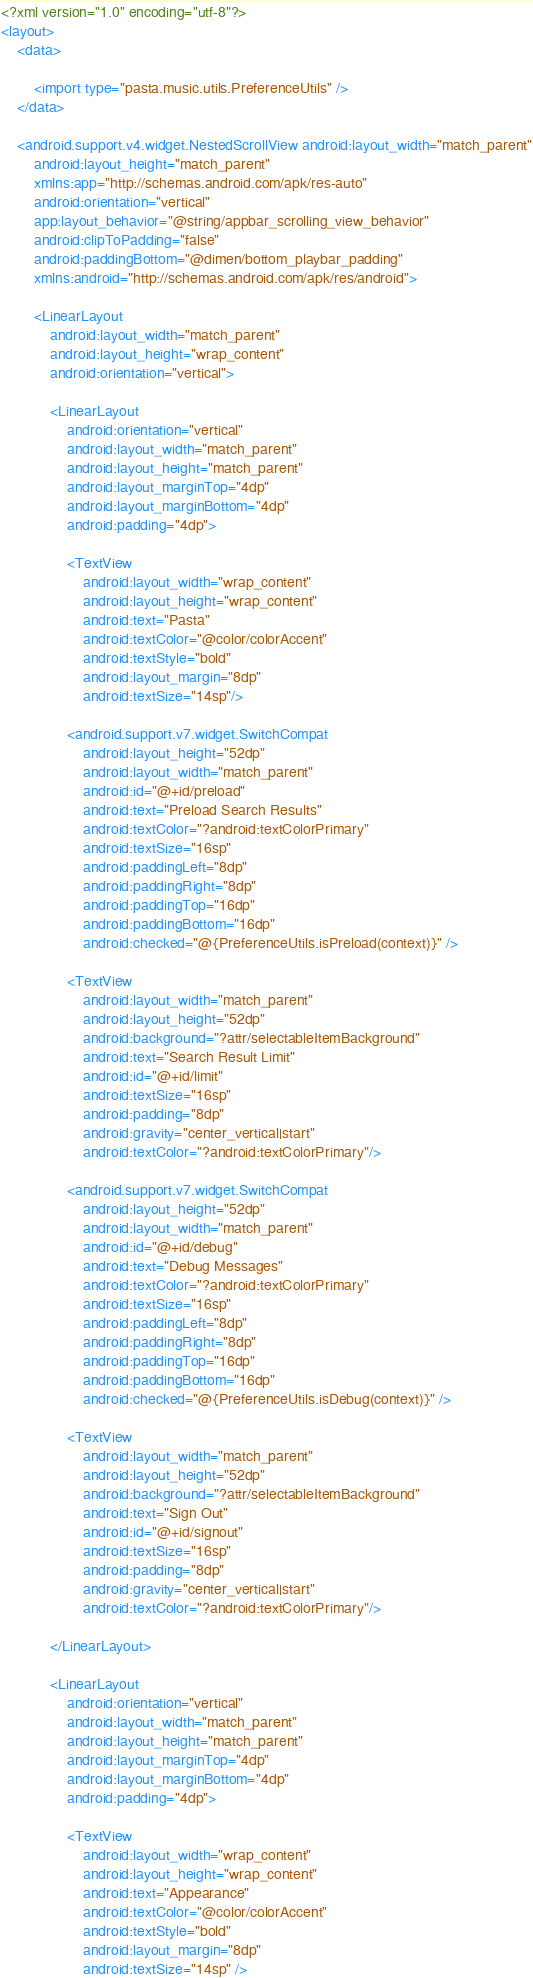Convert code to text. <code><loc_0><loc_0><loc_500><loc_500><_XML_><?xml version="1.0" encoding="utf-8"?>
<layout>
    <data>

        <import type="pasta.music.utils.PreferenceUtils" />
    </data>

    <android.support.v4.widget.NestedScrollView android:layout_width="match_parent"
        android:layout_height="match_parent"
        xmlns:app="http://schemas.android.com/apk/res-auto"
        android:orientation="vertical"
        app:layout_behavior="@string/appbar_scrolling_view_behavior"
        android:clipToPadding="false"
        android:paddingBottom="@dimen/bottom_playbar_padding"
        xmlns:android="http://schemas.android.com/apk/res/android">

        <LinearLayout
            android:layout_width="match_parent"
            android:layout_height="wrap_content"
            android:orientation="vertical">

            <LinearLayout
                android:orientation="vertical"
                android:layout_width="match_parent"
                android:layout_height="match_parent"
                android:layout_marginTop="4dp"
                android:layout_marginBottom="4dp"
                android:padding="4dp">

                <TextView
                    android:layout_width="wrap_content"
                    android:layout_height="wrap_content"
                    android:text="Pasta"
                    android:textColor="@color/colorAccent"
                    android:textStyle="bold"
                    android:layout_margin="8dp"
                    android:textSize="14sp"/>

                <android.support.v7.widget.SwitchCompat
                    android:layout_height="52dp"
                    android:layout_width="match_parent"
                    android:id="@+id/preload"
                    android:text="Preload Search Results"
                    android:textColor="?android:textColorPrimary"
                    android:textSize="16sp"
                    android:paddingLeft="8dp"
                    android:paddingRight="8dp"
                    android:paddingTop="16dp"
                    android:paddingBottom="16dp"
                    android:checked="@{PreferenceUtils.isPreload(context)}" />

                <TextView
                    android:layout_width="match_parent"
                    android:layout_height="52dp"
                    android:background="?attr/selectableItemBackground"
                    android:text="Search Result Limit"
                    android:id="@+id/limit"
                    android:textSize="16sp"
                    android:padding="8dp"
                    android:gravity="center_vertical|start"
                    android:textColor="?android:textColorPrimary"/>

                <android.support.v7.widget.SwitchCompat
                    android:layout_height="52dp"
                    android:layout_width="match_parent"
                    android:id="@+id/debug"
                    android:text="Debug Messages"
                    android:textColor="?android:textColorPrimary"
                    android:textSize="16sp"
                    android:paddingLeft="8dp"
                    android:paddingRight="8dp"
                    android:paddingTop="16dp"
                    android:paddingBottom="16dp"
                    android:checked="@{PreferenceUtils.isDebug(context)}" />

                <TextView
                    android:layout_width="match_parent"
                    android:layout_height="52dp"
                    android:background="?attr/selectableItemBackground"
                    android:text="Sign Out"
                    android:id="@+id/signout"
                    android:textSize="16sp"
                    android:padding="8dp"
                    android:gravity="center_vertical|start"
                    android:textColor="?android:textColorPrimary"/>

            </LinearLayout>

            <LinearLayout
                android:orientation="vertical"
                android:layout_width="match_parent"
                android:layout_height="match_parent"
                android:layout_marginTop="4dp"
                android:layout_marginBottom="4dp"
                android:padding="4dp">

                <TextView
                    android:layout_width="wrap_content"
                    android:layout_height="wrap_content"
                    android:text="Appearance"
                    android:textColor="@color/colorAccent"
                    android:textStyle="bold"
                    android:layout_margin="8dp"
                    android:textSize="14sp" />
</code> 